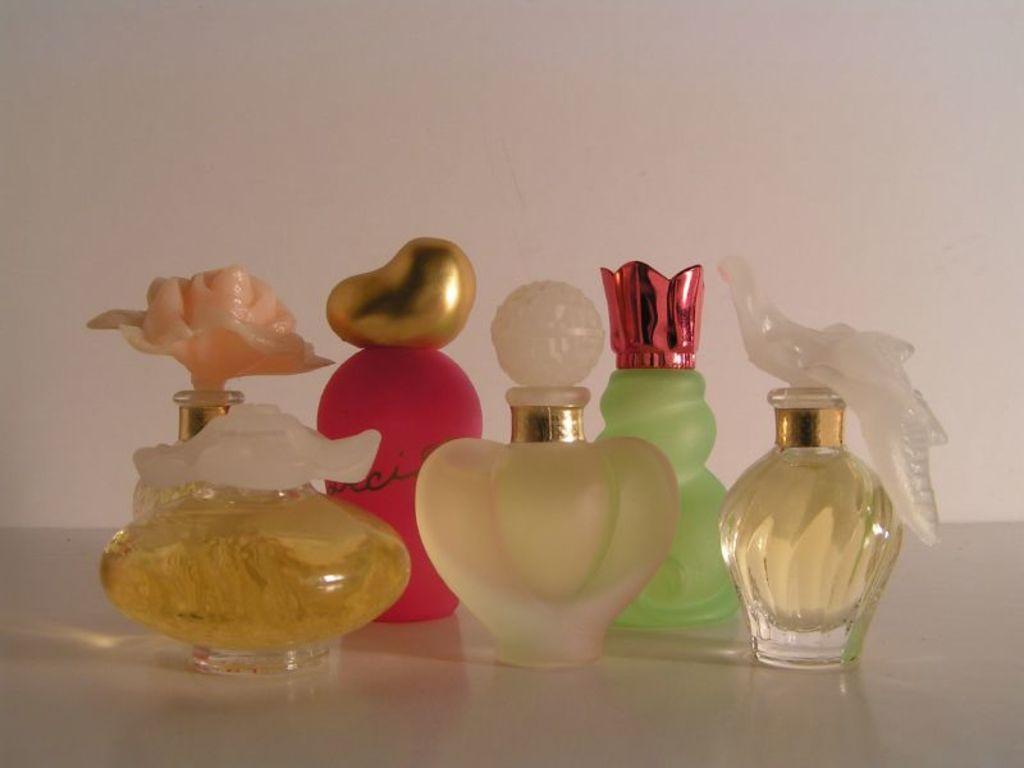In one or two sentences, can you explain what this image depicts? We can see bottles on the surface. Background we can see wall. 